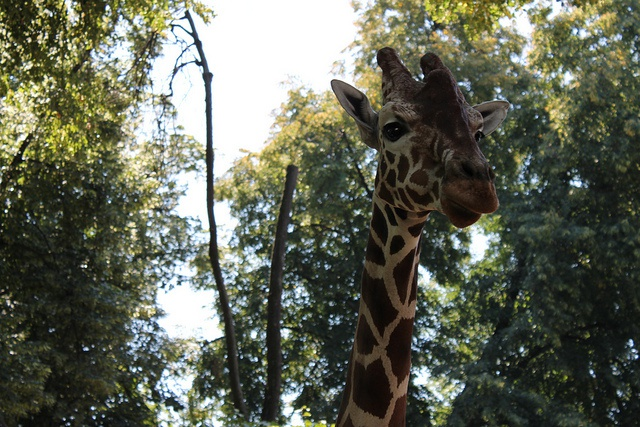Describe the objects in this image and their specific colors. I can see a giraffe in black and gray tones in this image. 